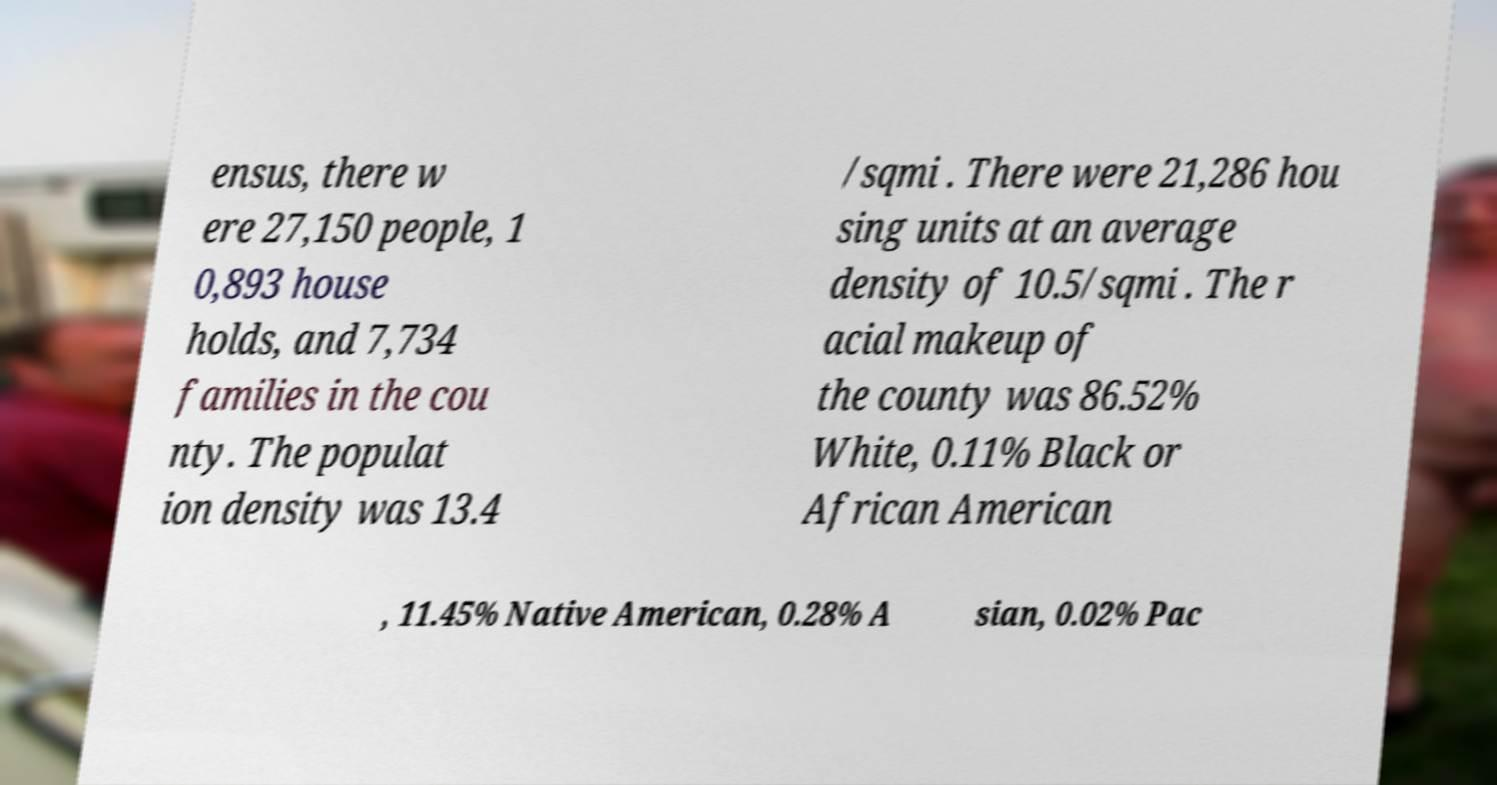Could you extract and type out the text from this image? ensus, there w ere 27,150 people, 1 0,893 house holds, and 7,734 families in the cou nty. The populat ion density was 13.4 /sqmi . There were 21,286 hou sing units at an average density of 10.5/sqmi . The r acial makeup of the county was 86.52% White, 0.11% Black or African American , 11.45% Native American, 0.28% A sian, 0.02% Pac 